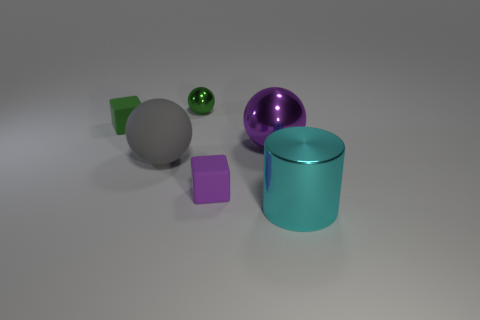There is a tiny green rubber thing; is it the same shape as the small rubber thing in front of the tiny green cube?
Give a very brief answer. Yes. There is a green block; what number of rubber blocks are right of it?
Keep it short and to the point. 1. There is a tiny rubber thing that is in front of the green matte cube; is it the same shape as the small green rubber object?
Offer a terse response. Yes. What color is the large object that is in front of the purple cube?
Ensure brevity in your answer.  Cyan. What shape is the purple thing that is made of the same material as the gray ball?
Give a very brief answer. Cube. Are there any other things that are the same color as the small ball?
Make the answer very short. Yes. Are there more small rubber things that are in front of the green matte object than tiny green things that are behind the small green sphere?
Make the answer very short. Yes. What number of cyan cylinders are the same size as the gray sphere?
Offer a terse response. 1. Are there fewer big metallic balls left of the green shiny ball than big purple balls that are right of the big rubber sphere?
Ensure brevity in your answer.  Yes. Is there a gray object that has the same shape as the tiny green metal object?
Offer a terse response. Yes. 